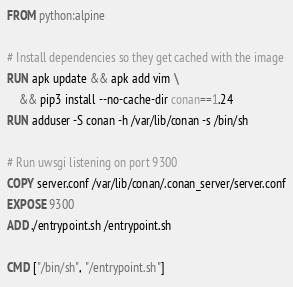Convert code to text. <code><loc_0><loc_0><loc_500><loc_500><_Dockerfile_>FROM python:alpine

# Install dependencies so they get cached with the image
RUN apk update && apk add vim \
    && pip3 install --no-cache-dir conan==1.24 
RUN adduser -S conan -h /var/lib/conan -s /bin/sh

# Run uwsgi listening on port 9300
COPY server.conf /var/lib/conan/.conan_server/server.conf
EXPOSE 9300
ADD ./entrypoint.sh /entrypoint.sh

CMD ["/bin/sh", "/entrypoint.sh"]
</code> 